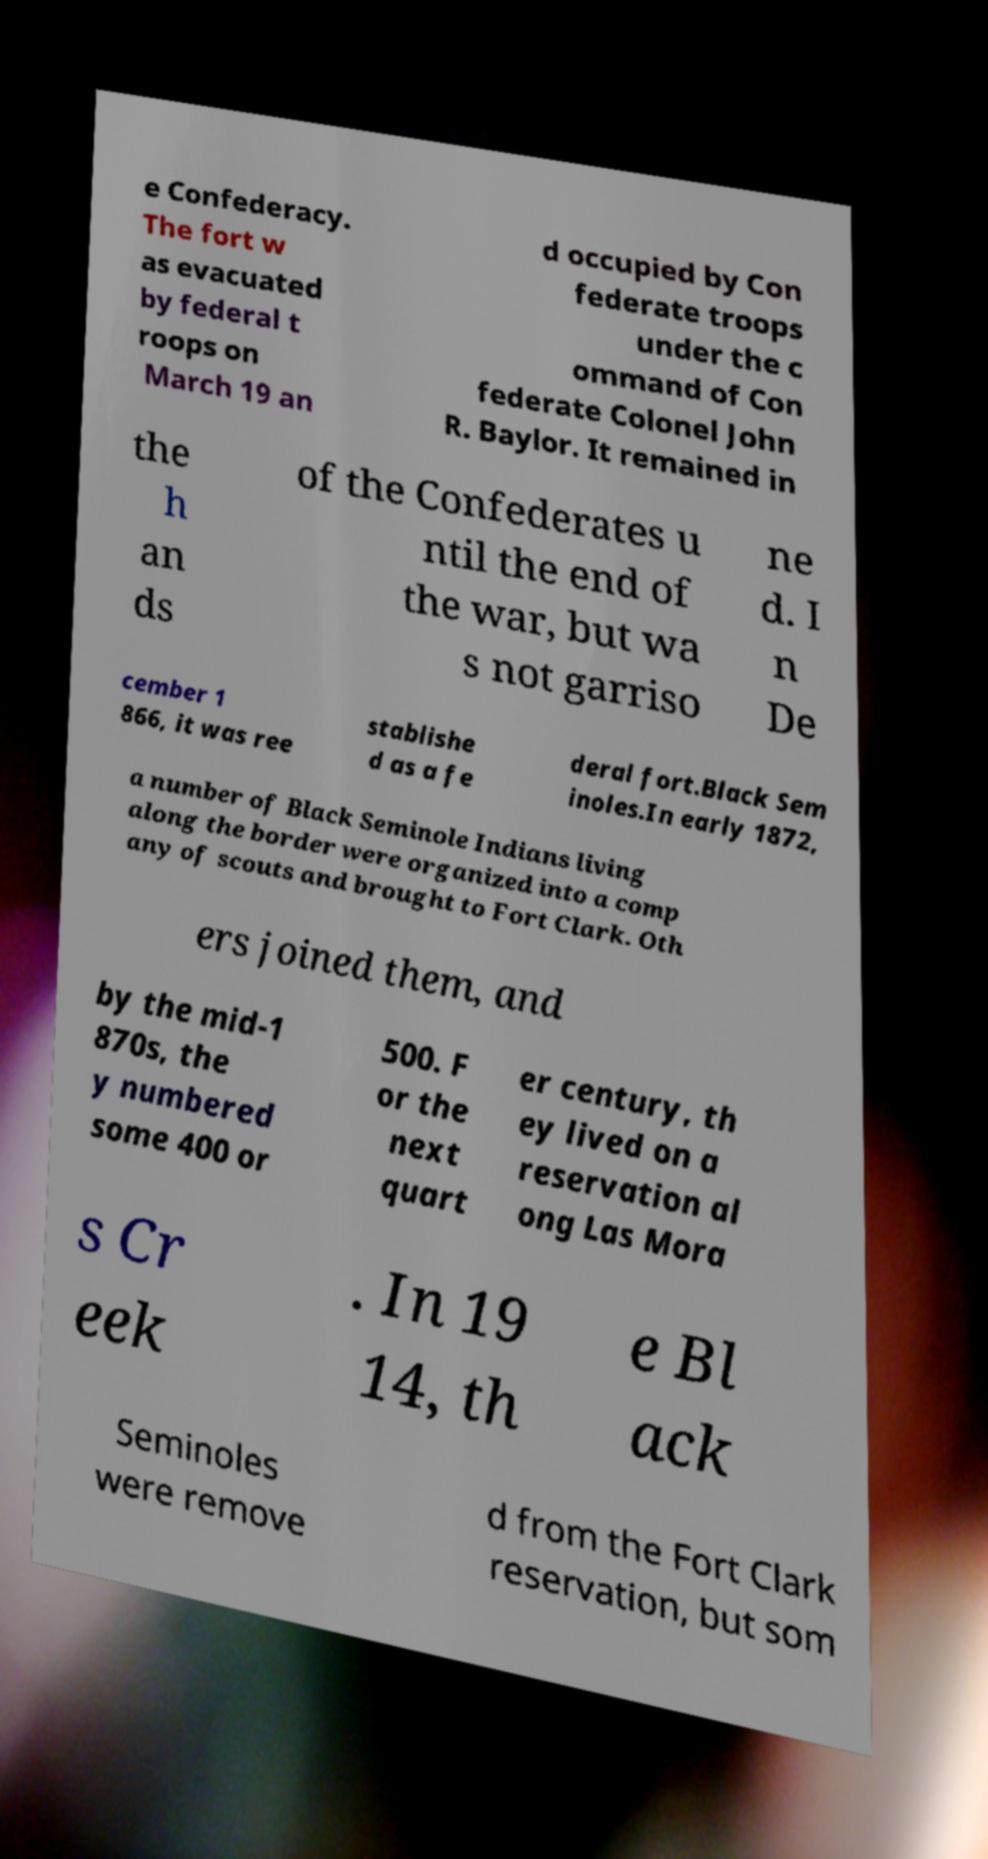There's text embedded in this image that I need extracted. Can you transcribe it verbatim? e Confederacy. The fort w as evacuated by federal t roops on March 19 an d occupied by Con federate troops under the c ommand of Con federate Colonel John R. Baylor. It remained in the h an ds of the Confederates u ntil the end of the war, but wa s not garriso ne d. I n De cember 1 866, it was ree stablishe d as a fe deral fort.Black Sem inoles.In early 1872, a number of Black Seminole Indians living along the border were organized into a comp any of scouts and brought to Fort Clark. Oth ers joined them, and by the mid-1 870s, the y numbered some 400 or 500. F or the next quart er century, th ey lived on a reservation al ong Las Mora s Cr eek . In 19 14, th e Bl ack Seminoles were remove d from the Fort Clark reservation, but som 